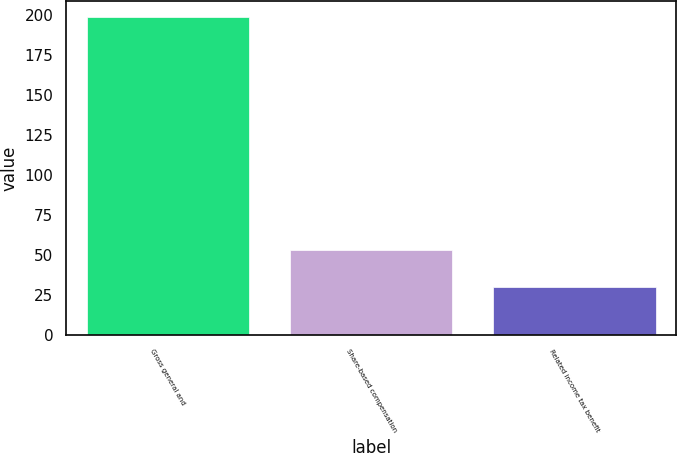Convert chart to OTSL. <chart><loc_0><loc_0><loc_500><loc_500><bar_chart><fcel>Gross general and<fcel>Share-based compensation<fcel>Related income tax benefit<nl><fcel>199<fcel>53<fcel>30<nl></chart> 